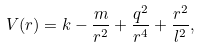Convert formula to latex. <formula><loc_0><loc_0><loc_500><loc_500>V ( r ) = k - \frac { m } { r ^ { 2 } } + \frac { q ^ { 2 } } { r ^ { 4 } } + \frac { r ^ { 2 } } { l ^ { 2 } } ,</formula> 